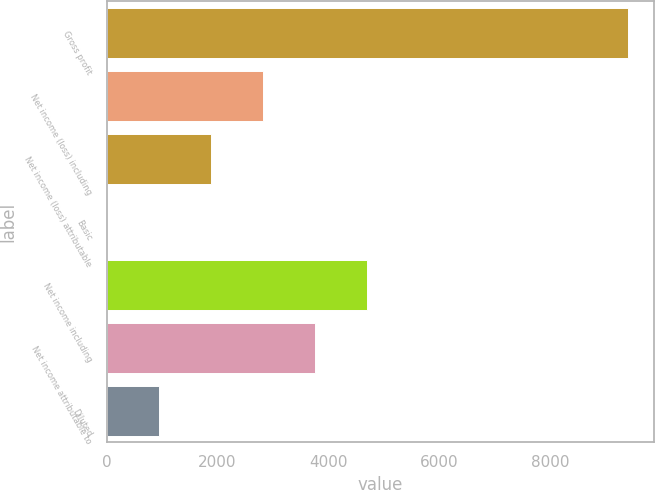Convert chart to OTSL. <chart><loc_0><loc_0><loc_500><loc_500><bar_chart><fcel>Gross profit<fcel>Net income (loss) including<fcel>Net income (loss) attributable<fcel>Basic<fcel>Net income including<fcel>Net income attributable to<fcel>Diluted<nl><fcel>9399<fcel>2820.78<fcel>1881.03<fcel>1.53<fcel>4700.28<fcel>3760.53<fcel>941.28<nl></chart> 